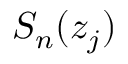<formula> <loc_0><loc_0><loc_500><loc_500>S _ { n } ( z _ { j } )</formula> 